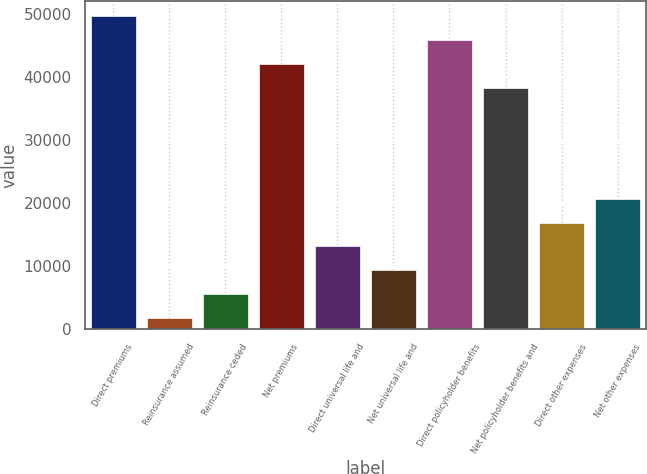Convert chart. <chart><loc_0><loc_0><loc_500><loc_500><bar_chart><fcel>Direct premiums<fcel>Reinsurance assumed<fcel>Reinsurance ceded<fcel>Net premiums<fcel>Direct universal life and<fcel>Net universal life and<fcel>Direct policyholder benefits<fcel>Net policyholder benefits and<fcel>Direct other expenses<fcel>Net other expenses<nl><fcel>49659.6<fcel>1773<fcel>5555.2<fcel>42095.2<fcel>13119.6<fcel>9337.4<fcel>45877.4<fcel>38313<fcel>16901.8<fcel>20684<nl></chart> 